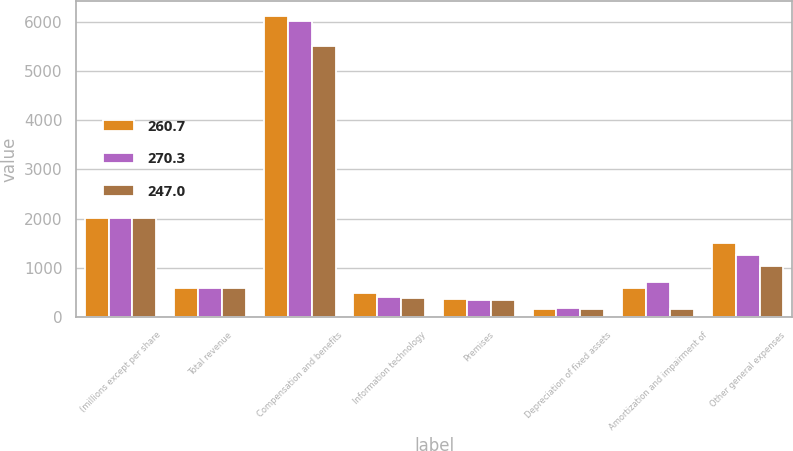Convert chart. <chart><loc_0><loc_0><loc_500><loc_500><stacked_bar_chart><ecel><fcel>(millions except per share<fcel>Total revenue<fcel>Compensation and benefits<fcel>Information technology<fcel>Premises<fcel>Depreciation of fixed assets<fcel>Amortization and impairment of<fcel>Other general expenses<nl><fcel>260.7<fcel>2018<fcel>593<fcel>6103<fcel>484<fcel>370<fcel>176<fcel>593<fcel>1500<nl><fcel>270.3<fcel>2017<fcel>593<fcel>6003<fcel>419<fcel>348<fcel>187<fcel>704<fcel>1272<nl><fcel>247<fcel>2016<fcel>593<fcel>5514<fcel>386<fcel>343<fcel>162<fcel>157<fcel>1036<nl></chart> 